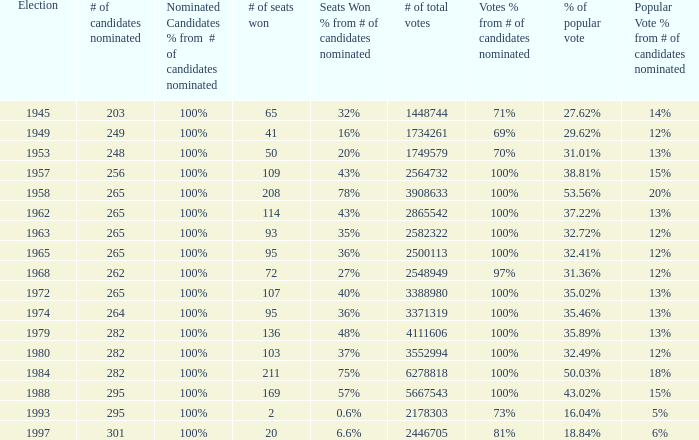What is the # of seats one for the election in 1974? 95.0. 